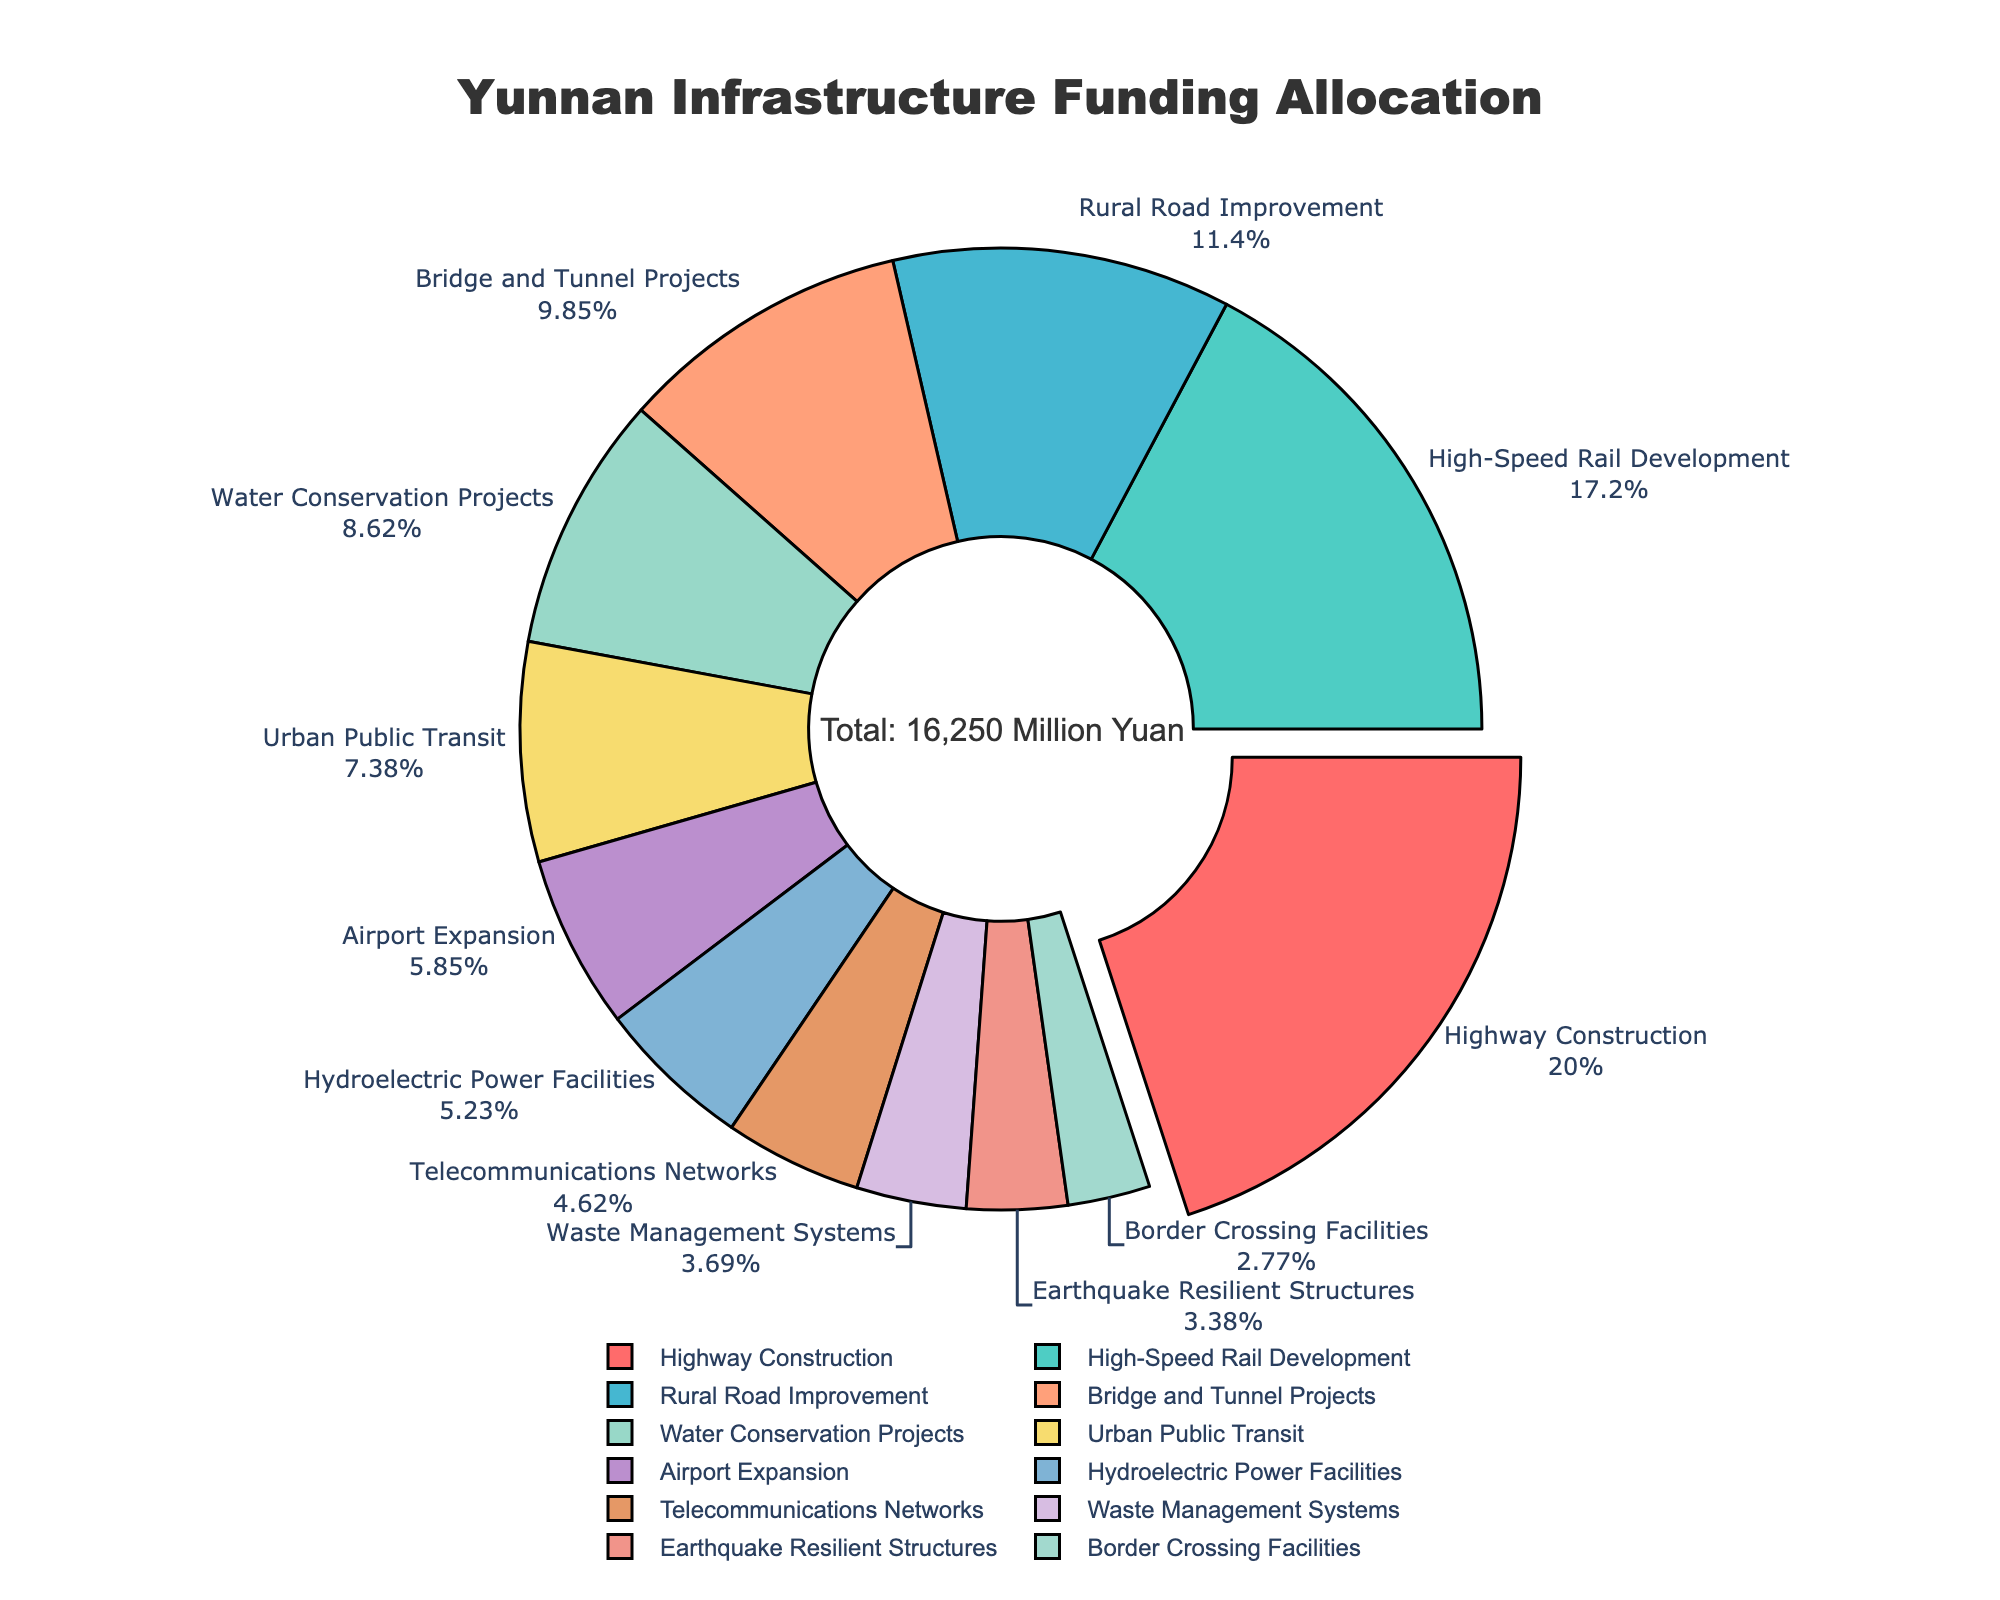Which infrastructure type received the highest allocation of funds? The category with the largest portion on the pie chart will be the one with the highest allocation. By looking at the pie chart, the largest section represents Highway Construction.
Answer: Highway Construction What percentage of the total funding was allocated to the High-Speed Rail Development? To find the percentage allocated to High-Speed Rail Development, locate its section on the pie chart and read the labeled percentage directly.
Answer: 17.23% How do the funds allocated to Bridge and Tunnel Projects compare to those allocated to Water Conservation Projects? By locating the two sections on the pie chart, compare their relative sizes and percentages. Bridge and Tunnel Projects have a larger section compared to Water Conservation Projects. Therefore, Bridge and Tunnel Projects have more funds allocated.
Answer: Bridge and Tunnel Projects have more funding What combined percentage of the total funding is allocated to Rural Road Improvement, Urban Public Transit, and Hydroelectric Power Facilities? Find the percentages for each of the three categories on the pie chart and add them together. The percentages are: Rural Road Improvement (11.38%), Urban Public Transit (7.38%), and Hydroelectric Power Facilities (5.23%). Adding these together gives 11.38% + 7.38% + 5.23% = 23.99%.
Answer: 23.99% Compare the allocations for Waste Management Systems and Telecommunications Networks. Which one has a greater allocation, and by how much? Locate both sections on the pie chart and find their respective percentages or funding values if provided. Waste Management Systems have 3.69%, and Telecommunications Networks have 4.62%. The difference can be calculated as 4.62% - 3.69% = 0.93%.
Answer: Telecommunications Networks by 0.93% Which two categories received the least amount of funding, and what is their combined allocation in million Yuan? Identify the two smallest sections on the pie chart, which represent the two types with the least funding. These are Border Crossing Facilities (450 million Yuan) and Earthquake Resilient Structures (550 million Yuan). Their combined allocation is 450 million Yuan + 550 million Yuan = 1000 million Yuan.
Answer: Border Crossing Facilities and Earthquake Resilient Structures, 1000 million Yuan What is the funding difference between High-Speed Rail Development and the sum of Airport Expansion and Telecommunications Networks? Identify the funding for High-Speed Rail Development (2800 million Yuan), Airport Expansion (950 million Yuan), and Telecommunications Networks (750 million Yuan). Sum the latter two: 950 million Yuan + 750 million Yuan = 1700 million Yuan. Subtract from High-Speed Rail Development: 2800 million Yuan - 1700 million Yuan = 1100 million Yuan.
Answer: 1100 million Yuan How many infrastructure types received an allocation of more than 1000 million Yuan? Count the sections on the pie chart that individually exceed 1000 million Yuan in funding. These are Highway Construction, High-Speed Rail Development, Rural Road Improvement, and Bridge and Tunnel Projects, totaling four types.
Answer: Four types 